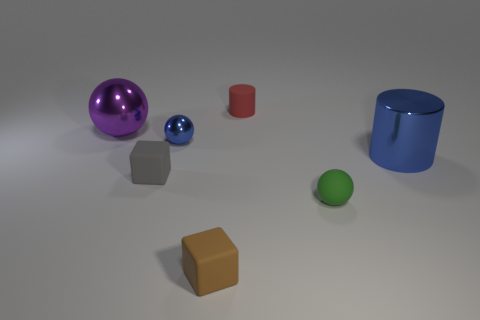Add 2 big purple things. How many objects exist? 9 Subtract all cylinders. How many objects are left? 5 Add 1 green things. How many green things are left? 2 Add 2 big purple rubber spheres. How many big purple rubber spheres exist? 2 Subtract 1 brown cubes. How many objects are left? 6 Subtract all cyan matte cylinders. Subtract all small red rubber cylinders. How many objects are left? 6 